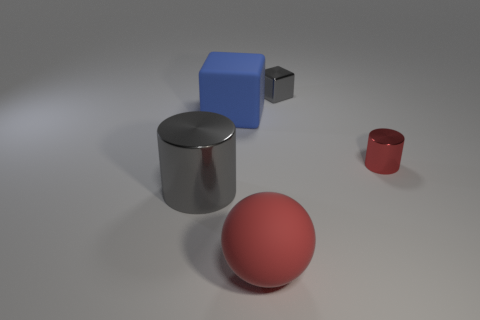Is the rubber sphere the same color as the small cylinder?
Provide a short and direct response. Yes. Are there any blocks that are behind the block right of the large rubber cube?
Provide a short and direct response. No. Does the gray object left of the big red thing have the same size as the cube on the left side of the sphere?
Provide a short and direct response. Yes. How many big things are shiny blocks or red objects?
Offer a terse response. 1. What is the material of the gray object in front of the thing that is behind the blue matte block?
Provide a succinct answer. Metal. There is a tiny thing that is the same color as the sphere; what shape is it?
Offer a terse response. Cylinder. Is there a blue cube made of the same material as the big red thing?
Your response must be concise. Yes. Is the sphere made of the same material as the block that is to the left of the rubber sphere?
Your answer should be compact. Yes. There is a matte object that is the same size as the ball; what color is it?
Your answer should be compact. Blue. What size is the cylinder that is to the right of the gray thing in front of the small cylinder?
Make the answer very short. Small. 